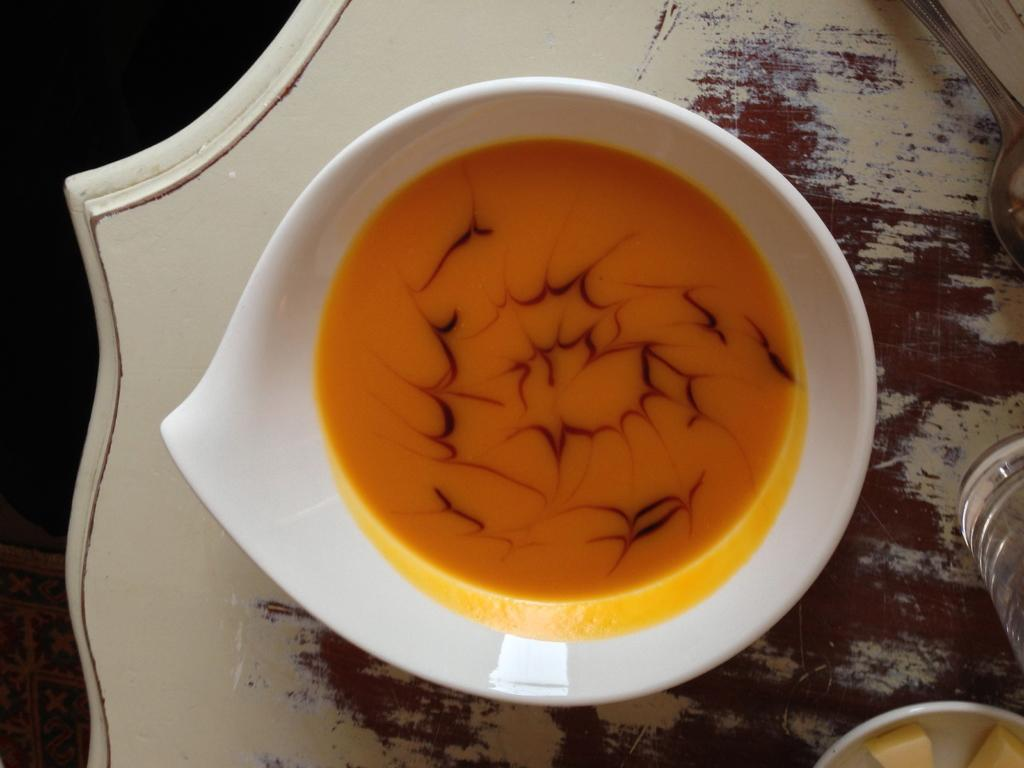What is the main food item in the image? There is a food item in a bowl in the image. Can you describe any other objects on the table in the image? Unfortunately, the provided facts do not give any information about other objects on the table. What type of toys are being destroyed by the cast in the image? There is no cast, toys, or destruction present in the image. 